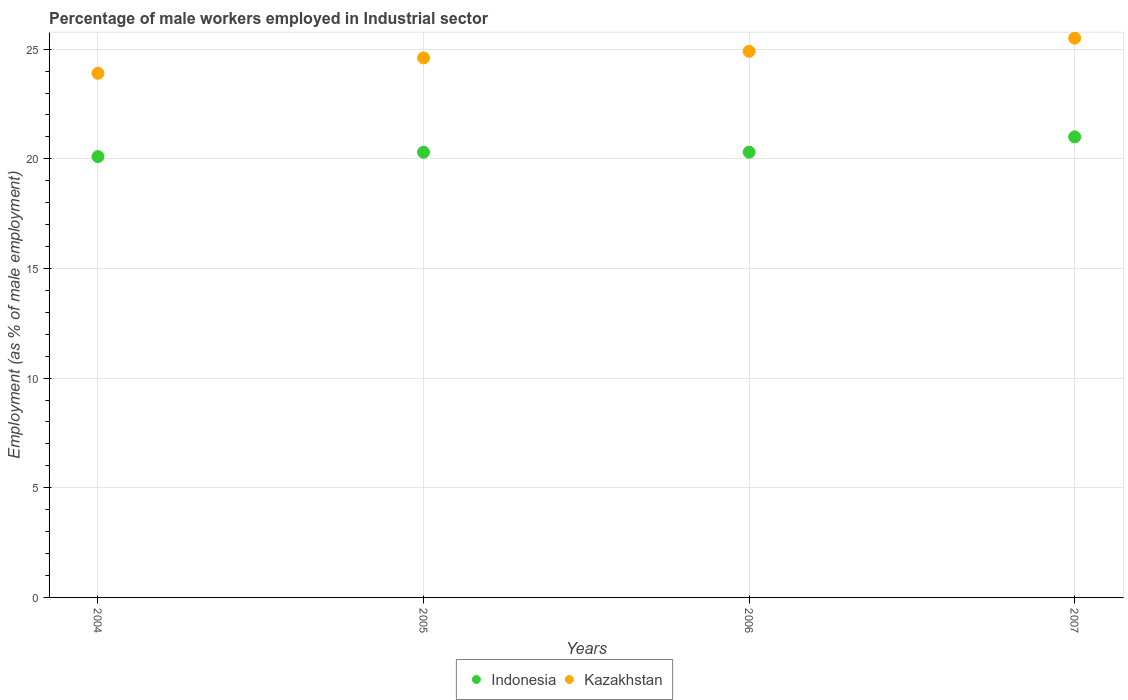What is the percentage of male workers employed in Industrial sector in Indonesia in 2004?
Provide a succinct answer. 20.1. Across all years, what is the maximum percentage of male workers employed in Industrial sector in Kazakhstan?
Give a very brief answer. 25.5. Across all years, what is the minimum percentage of male workers employed in Industrial sector in Kazakhstan?
Give a very brief answer. 23.9. In which year was the percentage of male workers employed in Industrial sector in Kazakhstan maximum?
Your answer should be very brief. 2007. What is the total percentage of male workers employed in Industrial sector in Indonesia in the graph?
Your response must be concise. 81.7. What is the difference between the percentage of male workers employed in Industrial sector in Indonesia in 2006 and that in 2007?
Your answer should be very brief. -0.7. What is the difference between the percentage of male workers employed in Industrial sector in Kazakhstan in 2005 and the percentage of male workers employed in Industrial sector in Indonesia in 2007?
Your response must be concise. 3.6. What is the average percentage of male workers employed in Industrial sector in Indonesia per year?
Provide a succinct answer. 20.42. In the year 2006, what is the difference between the percentage of male workers employed in Industrial sector in Kazakhstan and percentage of male workers employed in Industrial sector in Indonesia?
Your response must be concise. 4.6. In how many years, is the percentage of male workers employed in Industrial sector in Indonesia greater than 9 %?
Give a very brief answer. 4. What is the ratio of the percentage of male workers employed in Industrial sector in Kazakhstan in 2004 to that in 2007?
Offer a terse response. 0.94. Is the percentage of male workers employed in Industrial sector in Kazakhstan in 2005 less than that in 2007?
Provide a succinct answer. Yes. Is the difference between the percentage of male workers employed in Industrial sector in Kazakhstan in 2006 and 2007 greater than the difference between the percentage of male workers employed in Industrial sector in Indonesia in 2006 and 2007?
Offer a very short reply. Yes. What is the difference between the highest and the second highest percentage of male workers employed in Industrial sector in Indonesia?
Ensure brevity in your answer.  0.7. What is the difference between the highest and the lowest percentage of male workers employed in Industrial sector in Kazakhstan?
Provide a short and direct response. 1.6. In how many years, is the percentage of male workers employed in Industrial sector in Indonesia greater than the average percentage of male workers employed in Industrial sector in Indonesia taken over all years?
Provide a succinct answer. 1. Does the percentage of male workers employed in Industrial sector in Kazakhstan monotonically increase over the years?
Your answer should be very brief. Yes. Is the percentage of male workers employed in Industrial sector in Indonesia strictly greater than the percentage of male workers employed in Industrial sector in Kazakhstan over the years?
Offer a terse response. No. Is the percentage of male workers employed in Industrial sector in Indonesia strictly less than the percentage of male workers employed in Industrial sector in Kazakhstan over the years?
Provide a succinct answer. Yes. How many dotlines are there?
Keep it short and to the point. 2. What is the difference between two consecutive major ticks on the Y-axis?
Your response must be concise. 5. Does the graph contain any zero values?
Your response must be concise. No. Where does the legend appear in the graph?
Offer a very short reply. Bottom center. What is the title of the graph?
Provide a short and direct response. Percentage of male workers employed in Industrial sector. What is the label or title of the X-axis?
Provide a short and direct response. Years. What is the label or title of the Y-axis?
Your answer should be very brief. Employment (as % of male employment). What is the Employment (as % of male employment) of Indonesia in 2004?
Offer a terse response. 20.1. What is the Employment (as % of male employment) in Kazakhstan in 2004?
Your answer should be very brief. 23.9. What is the Employment (as % of male employment) of Indonesia in 2005?
Provide a succinct answer. 20.3. What is the Employment (as % of male employment) of Kazakhstan in 2005?
Keep it short and to the point. 24.6. What is the Employment (as % of male employment) of Indonesia in 2006?
Provide a short and direct response. 20.3. What is the Employment (as % of male employment) of Kazakhstan in 2006?
Offer a terse response. 24.9. What is the Employment (as % of male employment) in Kazakhstan in 2007?
Keep it short and to the point. 25.5. Across all years, what is the maximum Employment (as % of male employment) in Indonesia?
Ensure brevity in your answer.  21. Across all years, what is the maximum Employment (as % of male employment) of Kazakhstan?
Give a very brief answer. 25.5. Across all years, what is the minimum Employment (as % of male employment) in Indonesia?
Your answer should be compact. 20.1. Across all years, what is the minimum Employment (as % of male employment) of Kazakhstan?
Your response must be concise. 23.9. What is the total Employment (as % of male employment) of Indonesia in the graph?
Make the answer very short. 81.7. What is the total Employment (as % of male employment) in Kazakhstan in the graph?
Offer a very short reply. 98.9. What is the difference between the Employment (as % of male employment) in Indonesia in 2004 and that in 2005?
Give a very brief answer. -0.2. What is the difference between the Employment (as % of male employment) of Indonesia in 2004 and that in 2006?
Give a very brief answer. -0.2. What is the difference between the Employment (as % of male employment) in Kazakhstan in 2004 and that in 2007?
Give a very brief answer. -1.6. What is the difference between the Employment (as % of male employment) in Indonesia in 2005 and that in 2006?
Provide a succinct answer. 0. What is the difference between the Employment (as % of male employment) of Indonesia in 2005 and that in 2007?
Offer a very short reply. -0.7. What is the difference between the Employment (as % of male employment) of Kazakhstan in 2005 and that in 2007?
Ensure brevity in your answer.  -0.9. What is the difference between the Employment (as % of male employment) in Indonesia in 2006 and that in 2007?
Keep it short and to the point. -0.7. What is the difference between the Employment (as % of male employment) of Kazakhstan in 2006 and that in 2007?
Give a very brief answer. -0.6. What is the difference between the Employment (as % of male employment) of Indonesia in 2004 and the Employment (as % of male employment) of Kazakhstan in 2005?
Give a very brief answer. -4.5. What is the difference between the Employment (as % of male employment) of Indonesia in 2004 and the Employment (as % of male employment) of Kazakhstan in 2006?
Keep it short and to the point. -4.8. What is the difference between the Employment (as % of male employment) of Indonesia in 2004 and the Employment (as % of male employment) of Kazakhstan in 2007?
Make the answer very short. -5.4. What is the difference between the Employment (as % of male employment) of Indonesia in 2005 and the Employment (as % of male employment) of Kazakhstan in 2007?
Your response must be concise. -5.2. What is the difference between the Employment (as % of male employment) of Indonesia in 2006 and the Employment (as % of male employment) of Kazakhstan in 2007?
Your answer should be compact. -5.2. What is the average Employment (as % of male employment) of Indonesia per year?
Offer a very short reply. 20.43. What is the average Employment (as % of male employment) of Kazakhstan per year?
Keep it short and to the point. 24.73. In the year 2005, what is the difference between the Employment (as % of male employment) of Indonesia and Employment (as % of male employment) of Kazakhstan?
Make the answer very short. -4.3. In the year 2007, what is the difference between the Employment (as % of male employment) in Indonesia and Employment (as % of male employment) in Kazakhstan?
Make the answer very short. -4.5. What is the ratio of the Employment (as % of male employment) in Indonesia in 2004 to that in 2005?
Your answer should be very brief. 0.99. What is the ratio of the Employment (as % of male employment) of Kazakhstan in 2004 to that in 2005?
Offer a very short reply. 0.97. What is the ratio of the Employment (as % of male employment) of Indonesia in 2004 to that in 2006?
Offer a terse response. 0.99. What is the ratio of the Employment (as % of male employment) of Kazakhstan in 2004 to that in 2006?
Ensure brevity in your answer.  0.96. What is the ratio of the Employment (as % of male employment) in Indonesia in 2004 to that in 2007?
Provide a succinct answer. 0.96. What is the ratio of the Employment (as % of male employment) of Kazakhstan in 2004 to that in 2007?
Make the answer very short. 0.94. What is the ratio of the Employment (as % of male employment) of Indonesia in 2005 to that in 2006?
Give a very brief answer. 1. What is the ratio of the Employment (as % of male employment) in Indonesia in 2005 to that in 2007?
Provide a succinct answer. 0.97. What is the ratio of the Employment (as % of male employment) in Kazakhstan in 2005 to that in 2007?
Keep it short and to the point. 0.96. What is the ratio of the Employment (as % of male employment) of Indonesia in 2006 to that in 2007?
Ensure brevity in your answer.  0.97. What is the ratio of the Employment (as % of male employment) of Kazakhstan in 2006 to that in 2007?
Your response must be concise. 0.98. What is the difference between the highest and the second highest Employment (as % of male employment) of Kazakhstan?
Make the answer very short. 0.6. What is the difference between the highest and the lowest Employment (as % of male employment) of Kazakhstan?
Give a very brief answer. 1.6. 